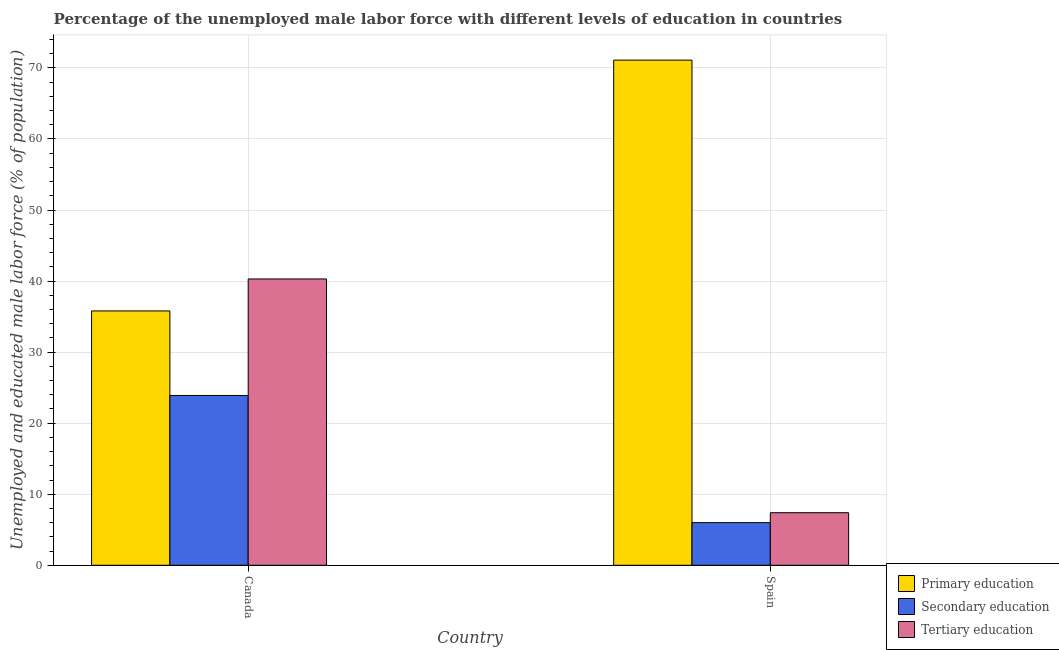How many different coloured bars are there?
Your answer should be compact. 3. How many bars are there on the 1st tick from the left?
Offer a very short reply. 3. What is the label of the 1st group of bars from the left?
Ensure brevity in your answer.  Canada. In how many cases, is the number of bars for a given country not equal to the number of legend labels?
Offer a very short reply. 0. What is the percentage of male labor force who received tertiary education in Spain?
Keep it short and to the point. 7.4. Across all countries, what is the maximum percentage of male labor force who received primary education?
Your response must be concise. 71.1. Across all countries, what is the minimum percentage of male labor force who received primary education?
Offer a very short reply. 35.8. In which country was the percentage of male labor force who received primary education maximum?
Offer a terse response. Spain. In which country was the percentage of male labor force who received secondary education minimum?
Provide a succinct answer. Spain. What is the total percentage of male labor force who received secondary education in the graph?
Offer a terse response. 29.9. What is the difference between the percentage of male labor force who received secondary education in Canada and that in Spain?
Your answer should be compact. 17.9. What is the difference between the percentage of male labor force who received primary education in Canada and the percentage of male labor force who received tertiary education in Spain?
Your answer should be compact. 28.4. What is the average percentage of male labor force who received primary education per country?
Offer a terse response. 53.45. What is the difference between the percentage of male labor force who received secondary education and percentage of male labor force who received tertiary education in Spain?
Keep it short and to the point. -1.4. What is the ratio of the percentage of male labor force who received primary education in Canada to that in Spain?
Give a very brief answer. 0.5. In how many countries, is the percentage of male labor force who received secondary education greater than the average percentage of male labor force who received secondary education taken over all countries?
Provide a short and direct response. 1. What does the 3rd bar from the right in Spain represents?
Keep it short and to the point. Primary education. Is it the case that in every country, the sum of the percentage of male labor force who received primary education and percentage of male labor force who received secondary education is greater than the percentage of male labor force who received tertiary education?
Provide a short and direct response. Yes. How many bars are there?
Keep it short and to the point. 6. What is the difference between two consecutive major ticks on the Y-axis?
Provide a succinct answer. 10. Does the graph contain any zero values?
Your answer should be very brief. No. Does the graph contain grids?
Make the answer very short. Yes. How many legend labels are there?
Your response must be concise. 3. What is the title of the graph?
Provide a short and direct response. Percentage of the unemployed male labor force with different levels of education in countries. What is the label or title of the X-axis?
Your answer should be very brief. Country. What is the label or title of the Y-axis?
Ensure brevity in your answer.  Unemployed and educated male labor force (% of population). What is the Unemployed and educated male labor force (% of population) in Primary education in Canada?
Provide a succinct answer. 35.8. What is the Unemployed and educated male labor force (% of population) of Secondary education in Canada?
Your answer should be compact. 23.9. What is the Unemployed and educated male labor force (% of population) of Tertiary education in Canada?
Provide a succinct answer. 40.3. What is the Unemployed and educated male labor force (% of population) of Primary education in Spain?
Offer a terse response. 71.1. What is the Unemployed and educated male labor force (% of population) of Tertiary education in Spain?
Keep it short and to the point. 7.4. Across all countries, what is the maximum Unemployed and educated male labor force (% of population) of Primary education?
Ensure brevity in your answer.  71.1. Across all countries, what is the maximum Unemployed and educated male labor force (% of population) of Secondary education?
Provide a short and direct response. 23.9. Across all countries, what is the maximum Unemployed and educated male labor force (% of population) in Tertiary education?
Provide a short and direct response. 40.3. Across all countries, what is the minimum Unemployed and educated male labor force (% of population) of Primary education?
Offer a terse response. 35.8. Across all countries, what is the minimum Unemployed and educated male labor force (% of population) of Tertiary education?
Keep it short and to the point. 7.4. What is the total Unemployed and educated male labor force (% of population) of Primary education in the graph?
Offer a very short reply. 106.9. What is the total Unemployed and educated male labor force (% of population) in Secondary education in the graph?
Provide a short and direct response. 29.9. What is the total Unemployed and educated male labor force (% of population) in Tertiary education in the graph?
Your answer should be compact. 47.7. What is the difference between the Unemployed and educated male labor force (% of population) of Primary education in Canada and that in Spain?
Make the answer very short. -35.3. What is the difference between the Unemployed and educated male labor force (% of population) of Secondary education in Canada and that in Spain?
Your answer should be very brief. 17.9. What is the difference between the Unemployed and educated male labor force (% of population) in Tertiary education in Canada and that in Spain?
Your response must be concise. 32.9. What is the difference between the Unemployed and educated male labor force (% of population) of Primary education in Canada and the Unemployed and educated male labor force (% of population) of Secondary education in Spain?
Offer a terse response. 29.8. What is the difference between the Unemployed and educated male labor force (% of population) in Primary education in Canada and the Unemployed and educated male labor force (% of population) in Tertiary education in Spain?
Your answer should be compact. 28.4. What is the average Unemployed and educated male labor force (% of population) of Primary education per country?
Give a very brief answer. 53.45. What is the average Unemployed and educated male labor force (% of population) in Secondary education per country?
Provide a succinct answer. 14.95. What is the average Unemployed and educated male labor force (% of population) of Tertiary education per country?
Give a very brief answer. 23.85. What is the difference between the Unemployed and educated male labor force (% of population) of Primary education and Unemployed and educated male labor force (% of population) of Secondary education in Canada?
Ensure brevity in your answer.  11.9. What is the difference between the Unemployed and educated male labor force (% of population) in Secondary education and Unemployed and educated male labor force (% of population) in Tertiary education in Canada?
Offer a terse response. -16.4. What is the difference between the Unemployed and educated male labor force (% of population) of Primary education and Unemployed and educated male labor force (% of population) of Secondary education in Spain?
Make the answer very short. 65.1. What is the difference between the Unemployed and educated male labor force (% of population) of Primary education and Unemployed and educated male labor force (% of population) of Tertiary education in Spain?
Offer a very short reply. 63.7. What is the difference between the Unemployed and educated male labor force (% of population) of Secondary education and Unemployed and educated male labor force (% of population) of Tertiary education in Spain?
Your answer should be compact. -1.4. What is the ratio of the Unemployed and educated male labor force (% of population) in Primary education in Canada to that in Spain?
Provide a short and direct response. 0.5. What is the ratio of the Unemployed and educated male labor force (% of population) of Secondary education in Canada to that in Spain?
Give a very brief answer. 3.98. What is the ratio of the Unemployed and educated male labor force (% of population) of Tertiary education in Canada to that in Spain?
Give a very brief answer. 5.45. What is the difference between the highest and the second highest Unemployed and educated male labor force (% of population) of Primary education?
Make the answer very short. 35.3. What is the difference between the highest and the second highest Unemployed and educated male labor force (% of population) in Secondary education?
Ensure brevity in your answer.  17.9. What is the difference between the highest and the second highest Unemployed and educated male labor force (% of population) in Tertiary education?
Provide a succinct answer. 32.9. What is the difference between the highest and the lowest Unemployed and educated male labor force (% of population) in Primary education?
Your answer should be compact. 35.3. What is the difference between the highest and the lowest Unemployed and educated male labor force (% of population) in Tertiary education?
Offer a very short reply. 32.9. 